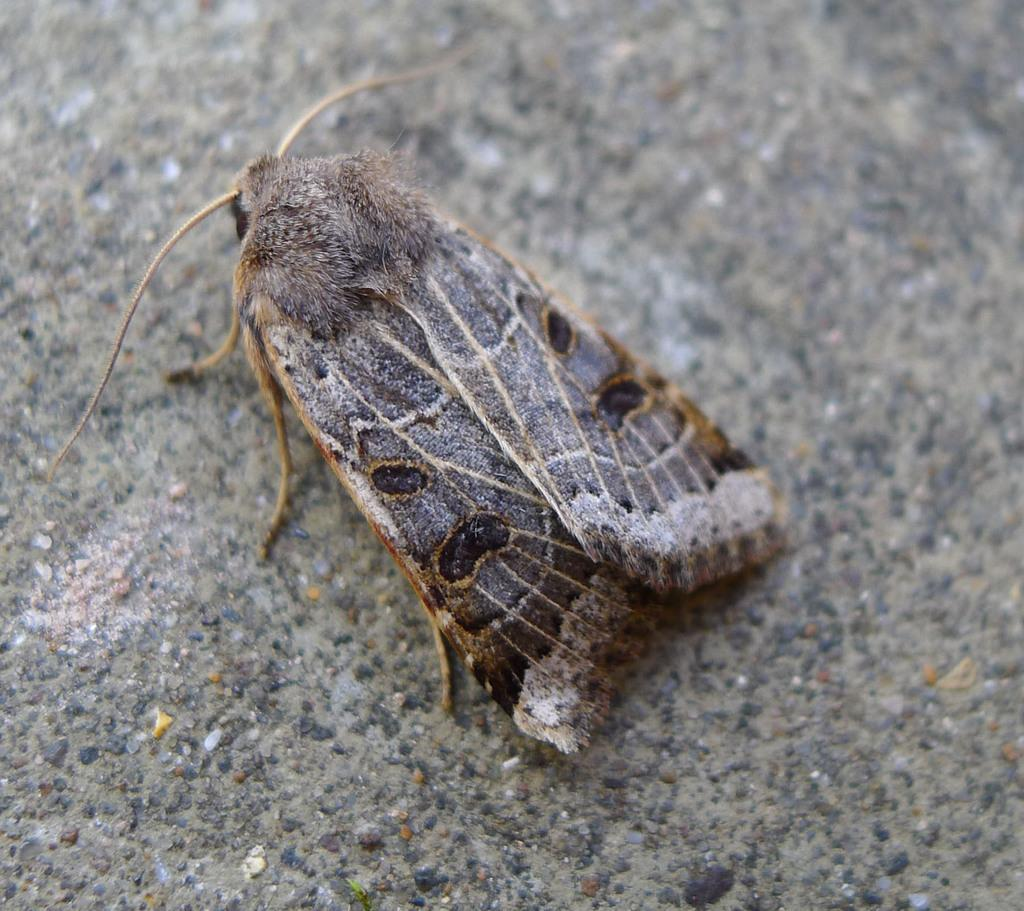What type of creature is in the image? There is an insect in the image. What colors can be seen on the insect? The insect has brown, grey, and black colors. What is the insect resting on in the image? The insect is on a grey surface. What type of bread is visible on the tray in the image? There is no bread or tray present in the image; it features an insect on a grey surface. What is the base made of that the insect is standing on in the image? There is no information about the base or its material in the image; it only shows an insect on a grey surface. 